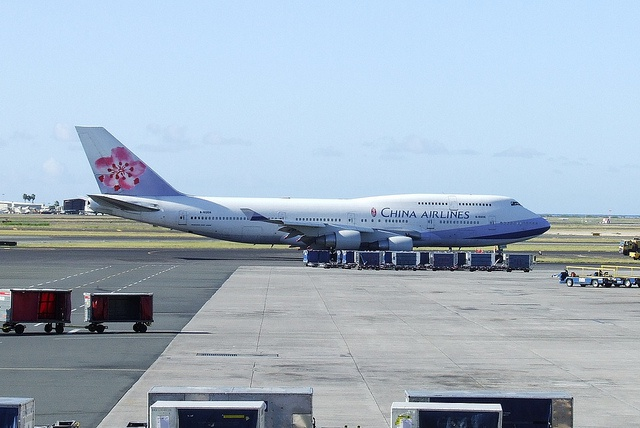Describe the objects in this image and their specific colors. I can see airplane in lightblue, gray, lightgray, and darkgray tones, truck in lightblue, black, darkgray, maroon, and gray tones, truck in lightblue, black, gray, darkgray, and lightgray tones, truck in lightblue, darkgray, black, lightgray, and gray tones, and airplane in lightblue, lightgray, darkgray, gray, and black tones in this image. 